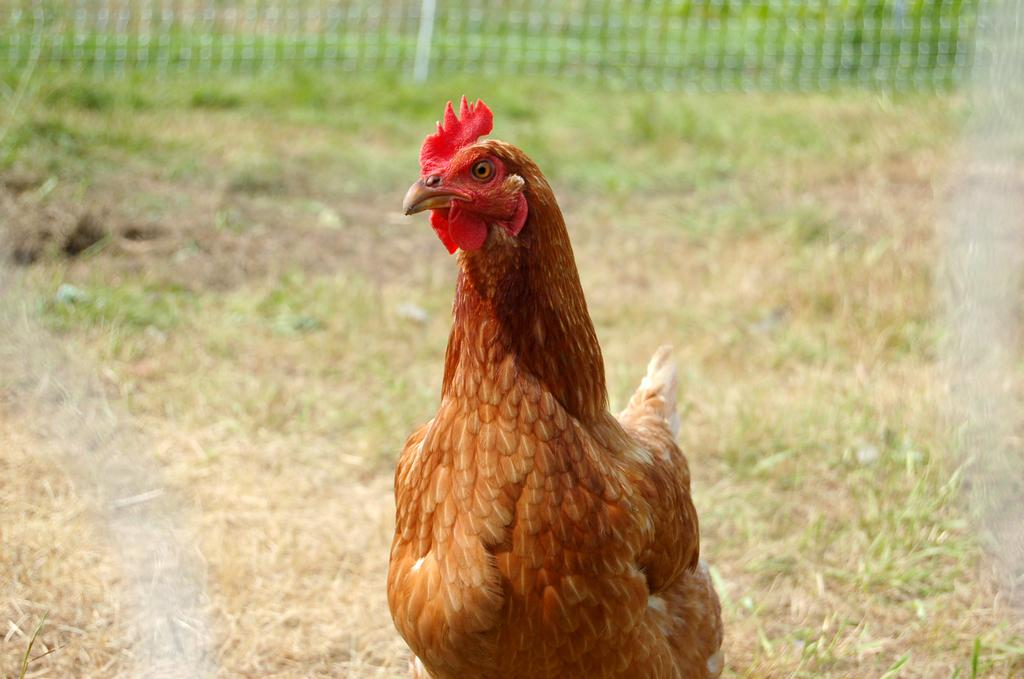What animal is the main subject of the image? There is a rooster in the image. What type of environment is visible in the background of the image? There is grass and a fence in the background of the image. How is the background of the image depicted? The background of the image is blurred. What rule is the rooster trying to enforce in the image? There is no indication in the image that the rooster is trying to enforce any rules. 